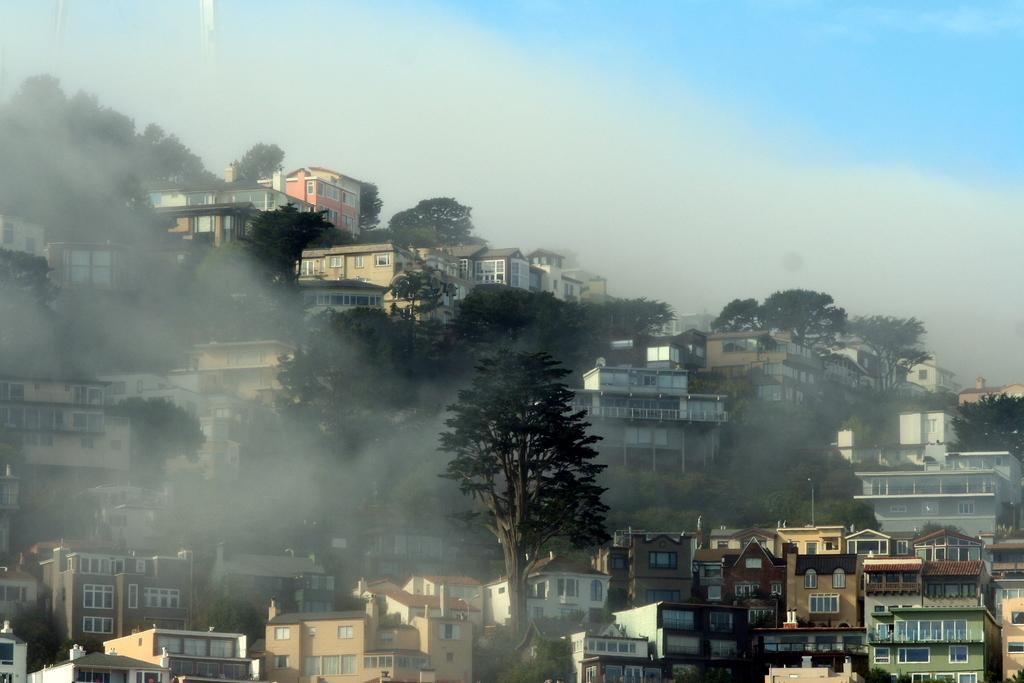What type of natural elements can be seen in the image? There are trees in the image. What type of man-made structures are present in the image? There are buildings in the image. What object can be seen standing upright in the image? There is a pole in the image. What can be seen in the background of the image? There are clouds and the sky visible in the background of the image. What type of juice is being served in the image? There is no juice present in the image. What time of day is it in the image? The time of day cannot be determined from the image, as there are no specific clues or indicators. 